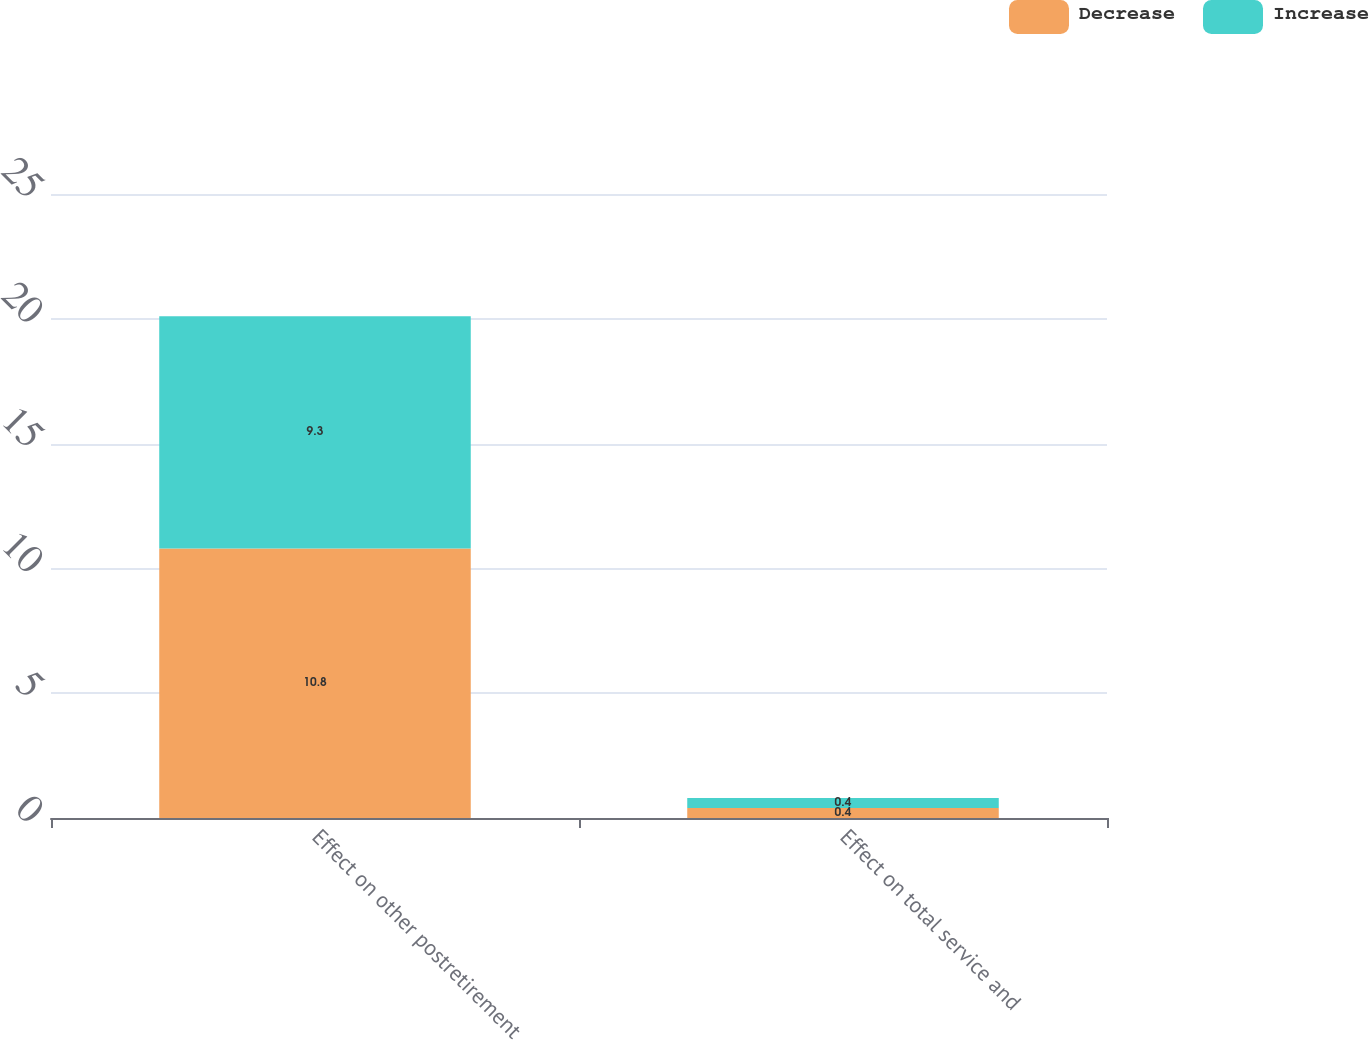Convert chart. <chart><loc_0><loc_0><loc_500><loc_500><stacked_bar_chart><ecel><fcel>Effect on other postretirement<fcel>Effect on total service and<nl><fcel>Decrease<fcel>10.8<fcel>0.4<nl><fcel>Increase<fcel>9.3<fcel>0.4<nl></chart> 